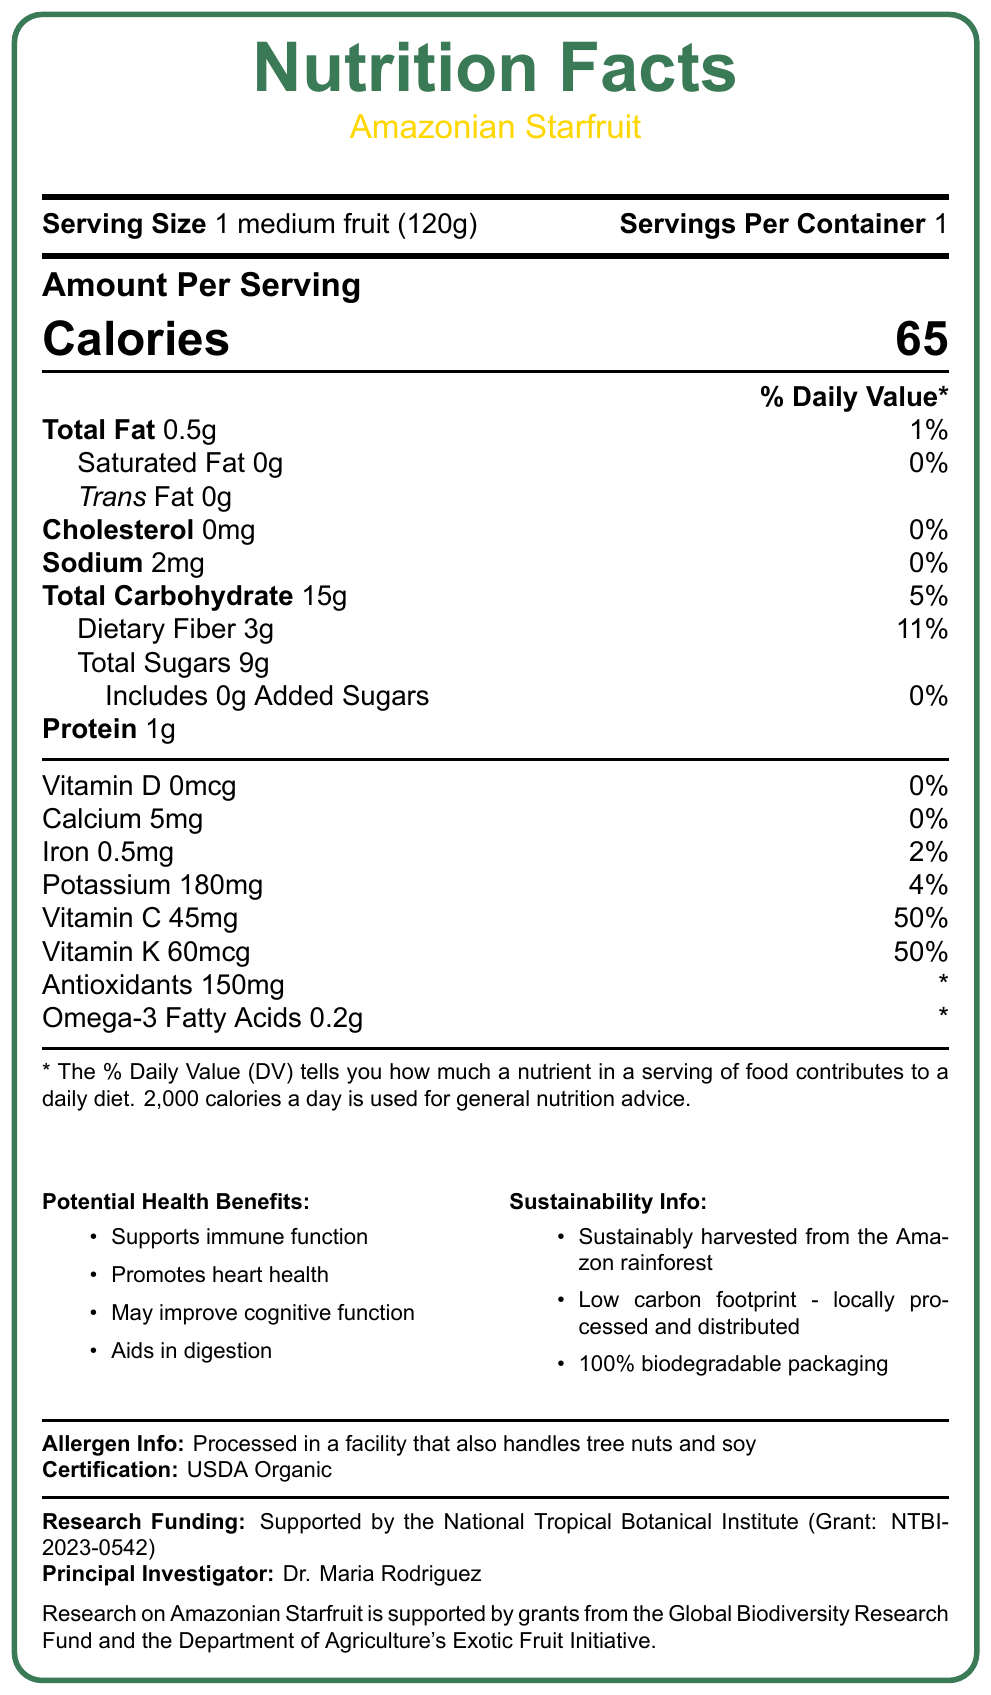what is the serving size of the Amazonian Starfruit? The serving size is clearly listed as "1 medium fruit (120g)" in the document.
Answer: 1 medium fruit (120g) how many calories are in one serving of Amazonian Starfruit? The amount of calories per serving is prominently displayed as 65.
Answer: 65 how much total fat is in a serving of the Amazonian Starfruit? The Nutrition Facts section lists the total fat as 0.5g.
Answer: 0.5g what are the main potential health benefits of consuming the Amazonian Starfruit? The potential health benefits are listed under the section titled "Potential Health Benefits" in bullet points.
Answer: Supports immune function, Promotes heart health, May improve cognitive function, Aids in digestion which institute is primarily funding the research on Amazonian Starfruit? The document states that the research funding is supported by the National Tropical Botanical Institute (Grant: NTBI-2023-0542).
Answer: National Tropical Botanical Institute what percentage of the daily value of Vitamin C does one serving of Amazonian Starfruit provide? The document shows that one serving of Amazonian Starfruit provides 50% of the daily value of Vitamin C.
Answer: 50% what is the sodium content per serving of Amazonian Starfruit? The sodium content is detailed as 2mg per serving.
Answer: 2mg how much dietary fiber is in a single serving? The document specifies that each serving contains 3g of dietary fiber.
Answer: 3g how is the Amazonian Starfruit sourced? The sustainability information section states that the fruit is sustainably harvested from the Amazon rainforest.
Answer: Sustainably harvested from the Amazon rainforest how much potassium is in one serving of Amazonian Starfruit? A. 180mg B. 200mg C. 150mg D. 100mg The document lists 180mg of potassium per serving.
Answer: A. 180mg how much omega-3 fatty acids does one serving of Amazonian Starfruit contain? A. 0.5g B. 0.2g C. 0.05g D. 1g The omega-3 fatty acids content is 0.2g per serving as per the document.
Answer: B. 0.2g is the Amazonian Starfruit certified organic? Yes or No The document specifies that the Amazonian Starfruit is USDA Organic certified.
Answer: Yes provide a summary of the information on the Nutrition Facts label for Amazonian Starfruit. This summary covers all main points from the document, including nutritional information, health benefits, sustainability, and research funding.
Answer: The Amazonian Starfruit Nutrition Facts label provides detailed information about its serving size (1 medium fruit, 120g), calories (65 per serving), and nutrient content, including 0.5g total fat, 0g saturated and trans fats, 2mg sodium, 15g total carbohydrates (with 3g dietary fiber and 9g total sugars), 1g protein, 45mg vitamin C (50% DV), 60mcg vitamin K (50% DV), 180mg potassium (4% DV), 150mg antioxidants, and 0.2g omega-3 fatty acids. Potential health benefits include immune support, heart health, cognitive function, and digestion aid. Sustainable sourcing, low carbon footprint, and biodegradable packaging are emphasized, along with allergen info, and research funding details. how many milligrams of antioxidants are in a serving of Amazonian Starfruit? While the document mentions that a serving contains 150mg of antioxidants, it does not specify the significance of this amount in terms of daily value. Hence, we cannot determine the % DV contribution.
Answer: Not enough information how many servings are there per container of Amazonian Starfruit? The document clearly indicates that there is 1 serving per container.
Answer: 1 is the Amazonian Starfruit high in added sugars? The document indicates that there are 0g of added sugars in a serving.
Answer: No who is the principal investigator of the research funded by the National Tropical Botanical Institute? The document lists Dr. Maria Rodriguez as the principal investigator.
Answer: Dr. Maria Rodriguez 